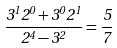Convert formula to latex. <formula><loc_0><loc_0><loc_500><loc_500>\frac { 3 ^ { 1 } 2 ^ { 0 } + 3 ^ { 0 } 2 ^ { 1 } } { 2 ^ { 4 } - 3 ^ { 2 } } = \frac { 5 } { 7 }</formula> 